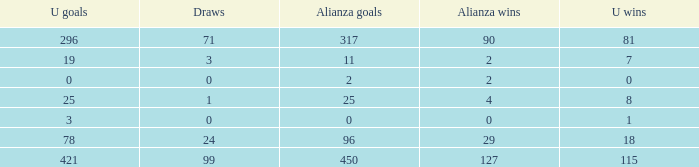What is the lowest Draws, when Alianza Goals is less than 317, when U Goals is less than 3, and when Alianza Wins is less than 2? None. 